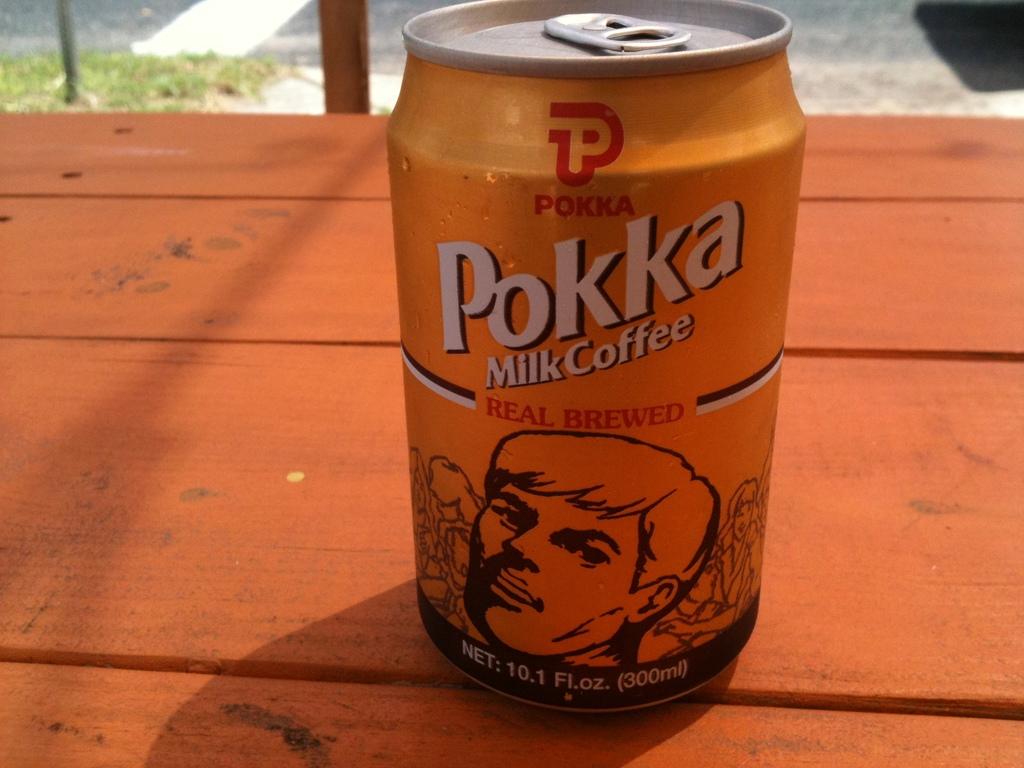What type of coffee is this?
Offer a terse response. Milk. 